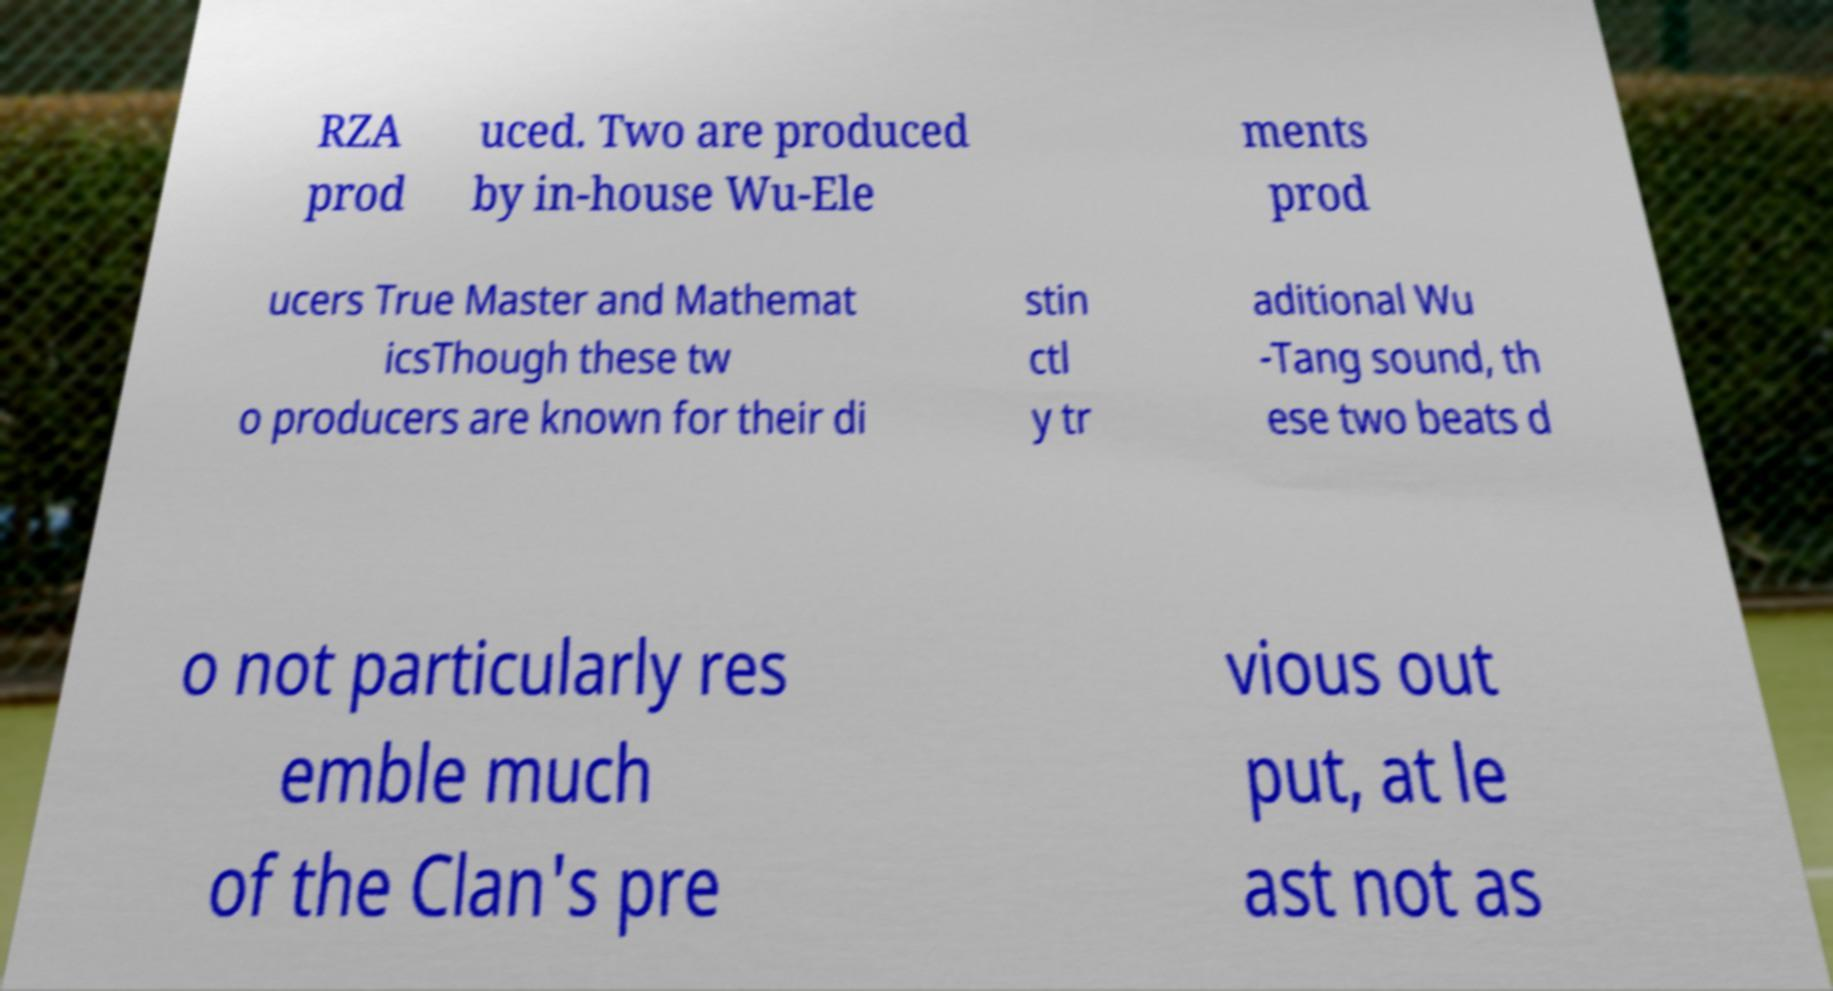There's text embedded in this image that I need extracted. Can you transcribe it verbatim? RZA prod uced. Two are produced by in-house Wu-Ele ments prod ucers True Master and Mathemat icsThough these tw o producers are known for their di stin ctl y tr aditional Wu -Tang sound, th ese two beats d o not particularly res emble much of the Clan's pre vious out put, at le ast not as 